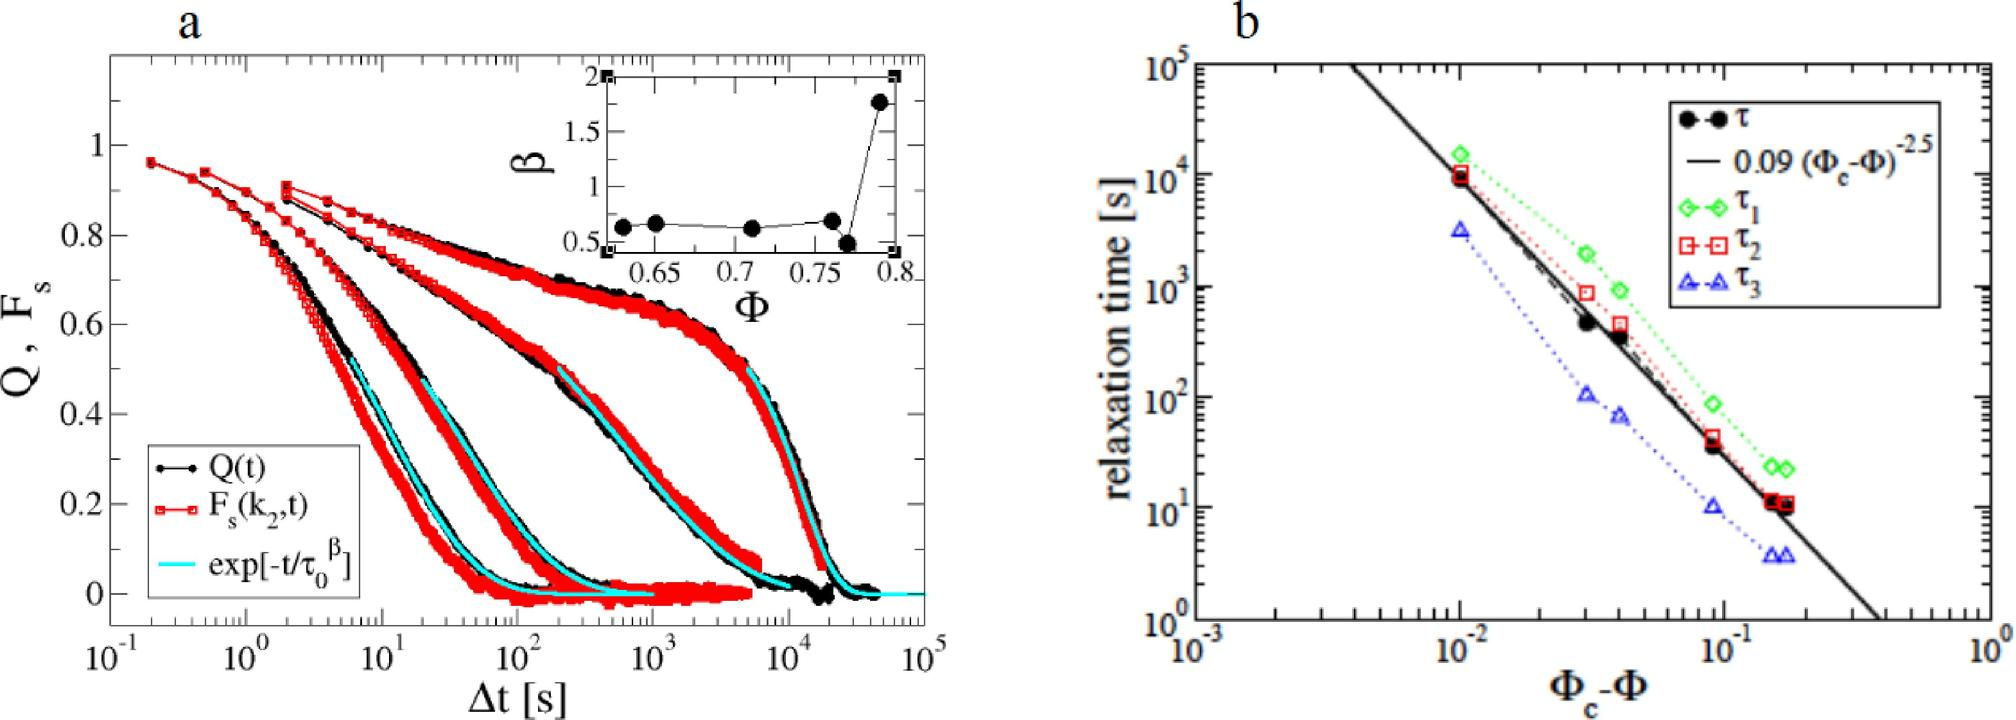What is the significance of having both solid and dashed lines in the graph of figure b? In figure b, the presence of both solid and dashed lines serves a specific purpose. The solid lines generally represent the actual observed data points or experimental results of the relaxation times for different 
 values. Conversely, the dashed lines typically depict theoretical models or fits to the data, such as the black dashed line showing a fit with the functional form given by the equation '0.09 (
 - 
_c)^-2.5'. This combination allows for a comparative analysis between theory (dashed lines) and experiment (solid lines), highlighting how well theoretical predictions align with empirical observations. 